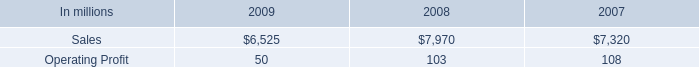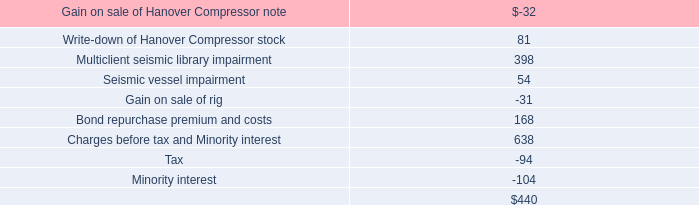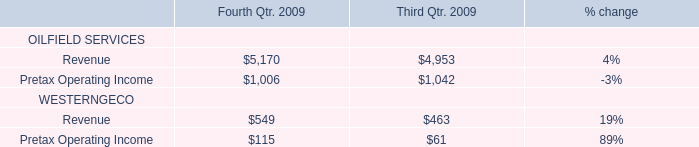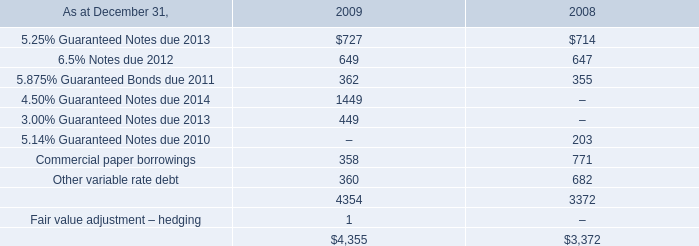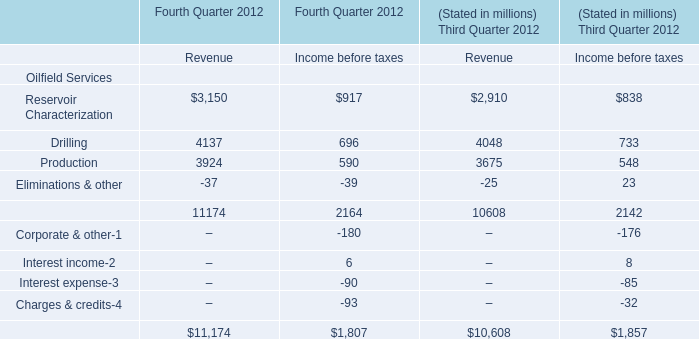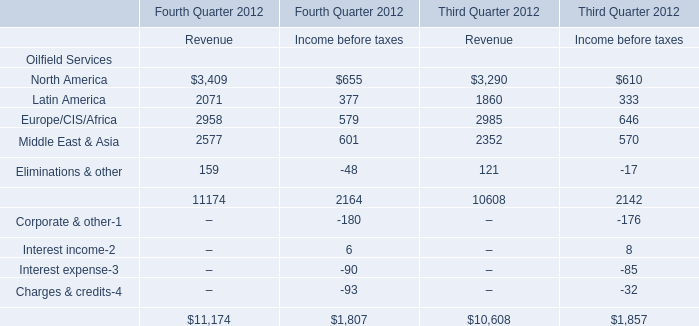What is the percentage of all Revenue that are positive to the total amount, in 2012 for Third Quarter 2012? 
Computations: (((((3290 + 1860) + 2985) + 2352) + 121) / 10608)
Answer: 1.0. 